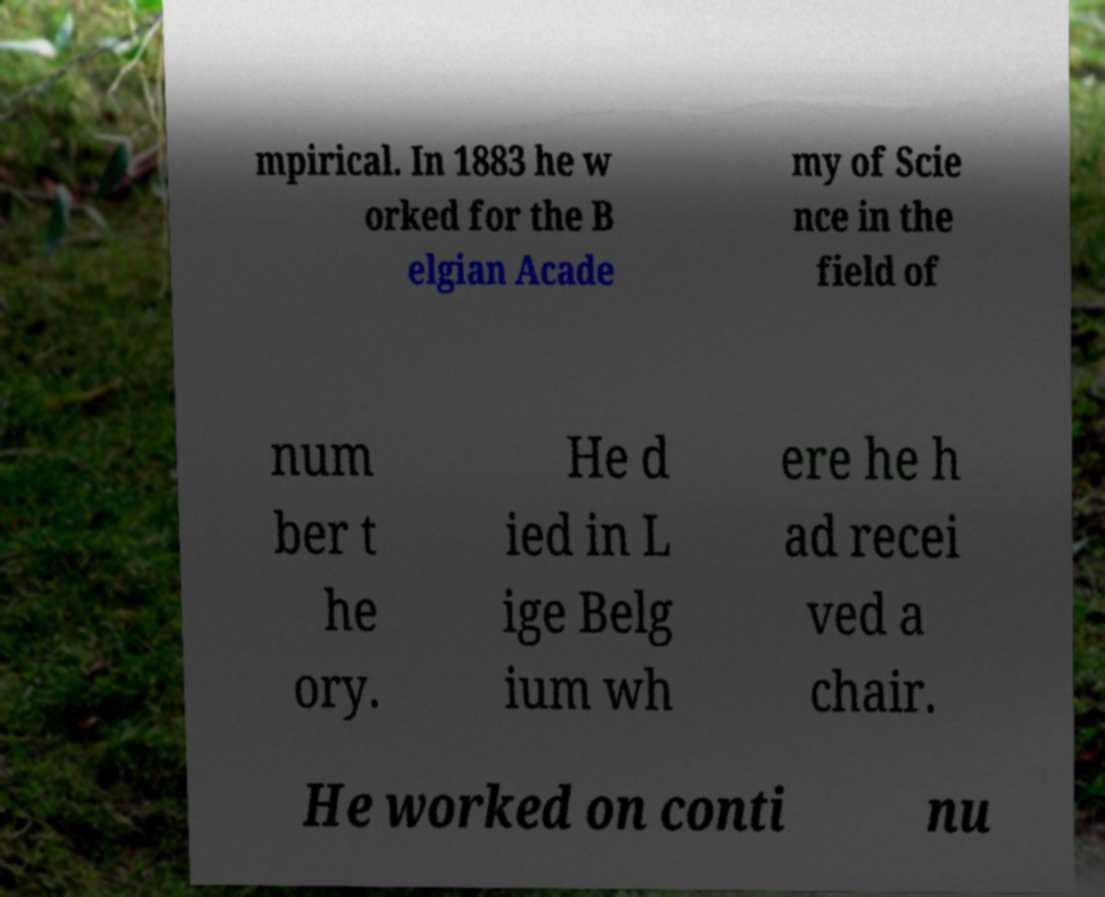What messages or text are displayed in this image? I need them in a readable, typed format. mpirical. In 1883 he w orked for the B elgian Acade my of Scie nce in the field of num ber t he ory. He d ied in L ige Belg ium wh ere he h ad recei ved a chair. He worked on conti nu 